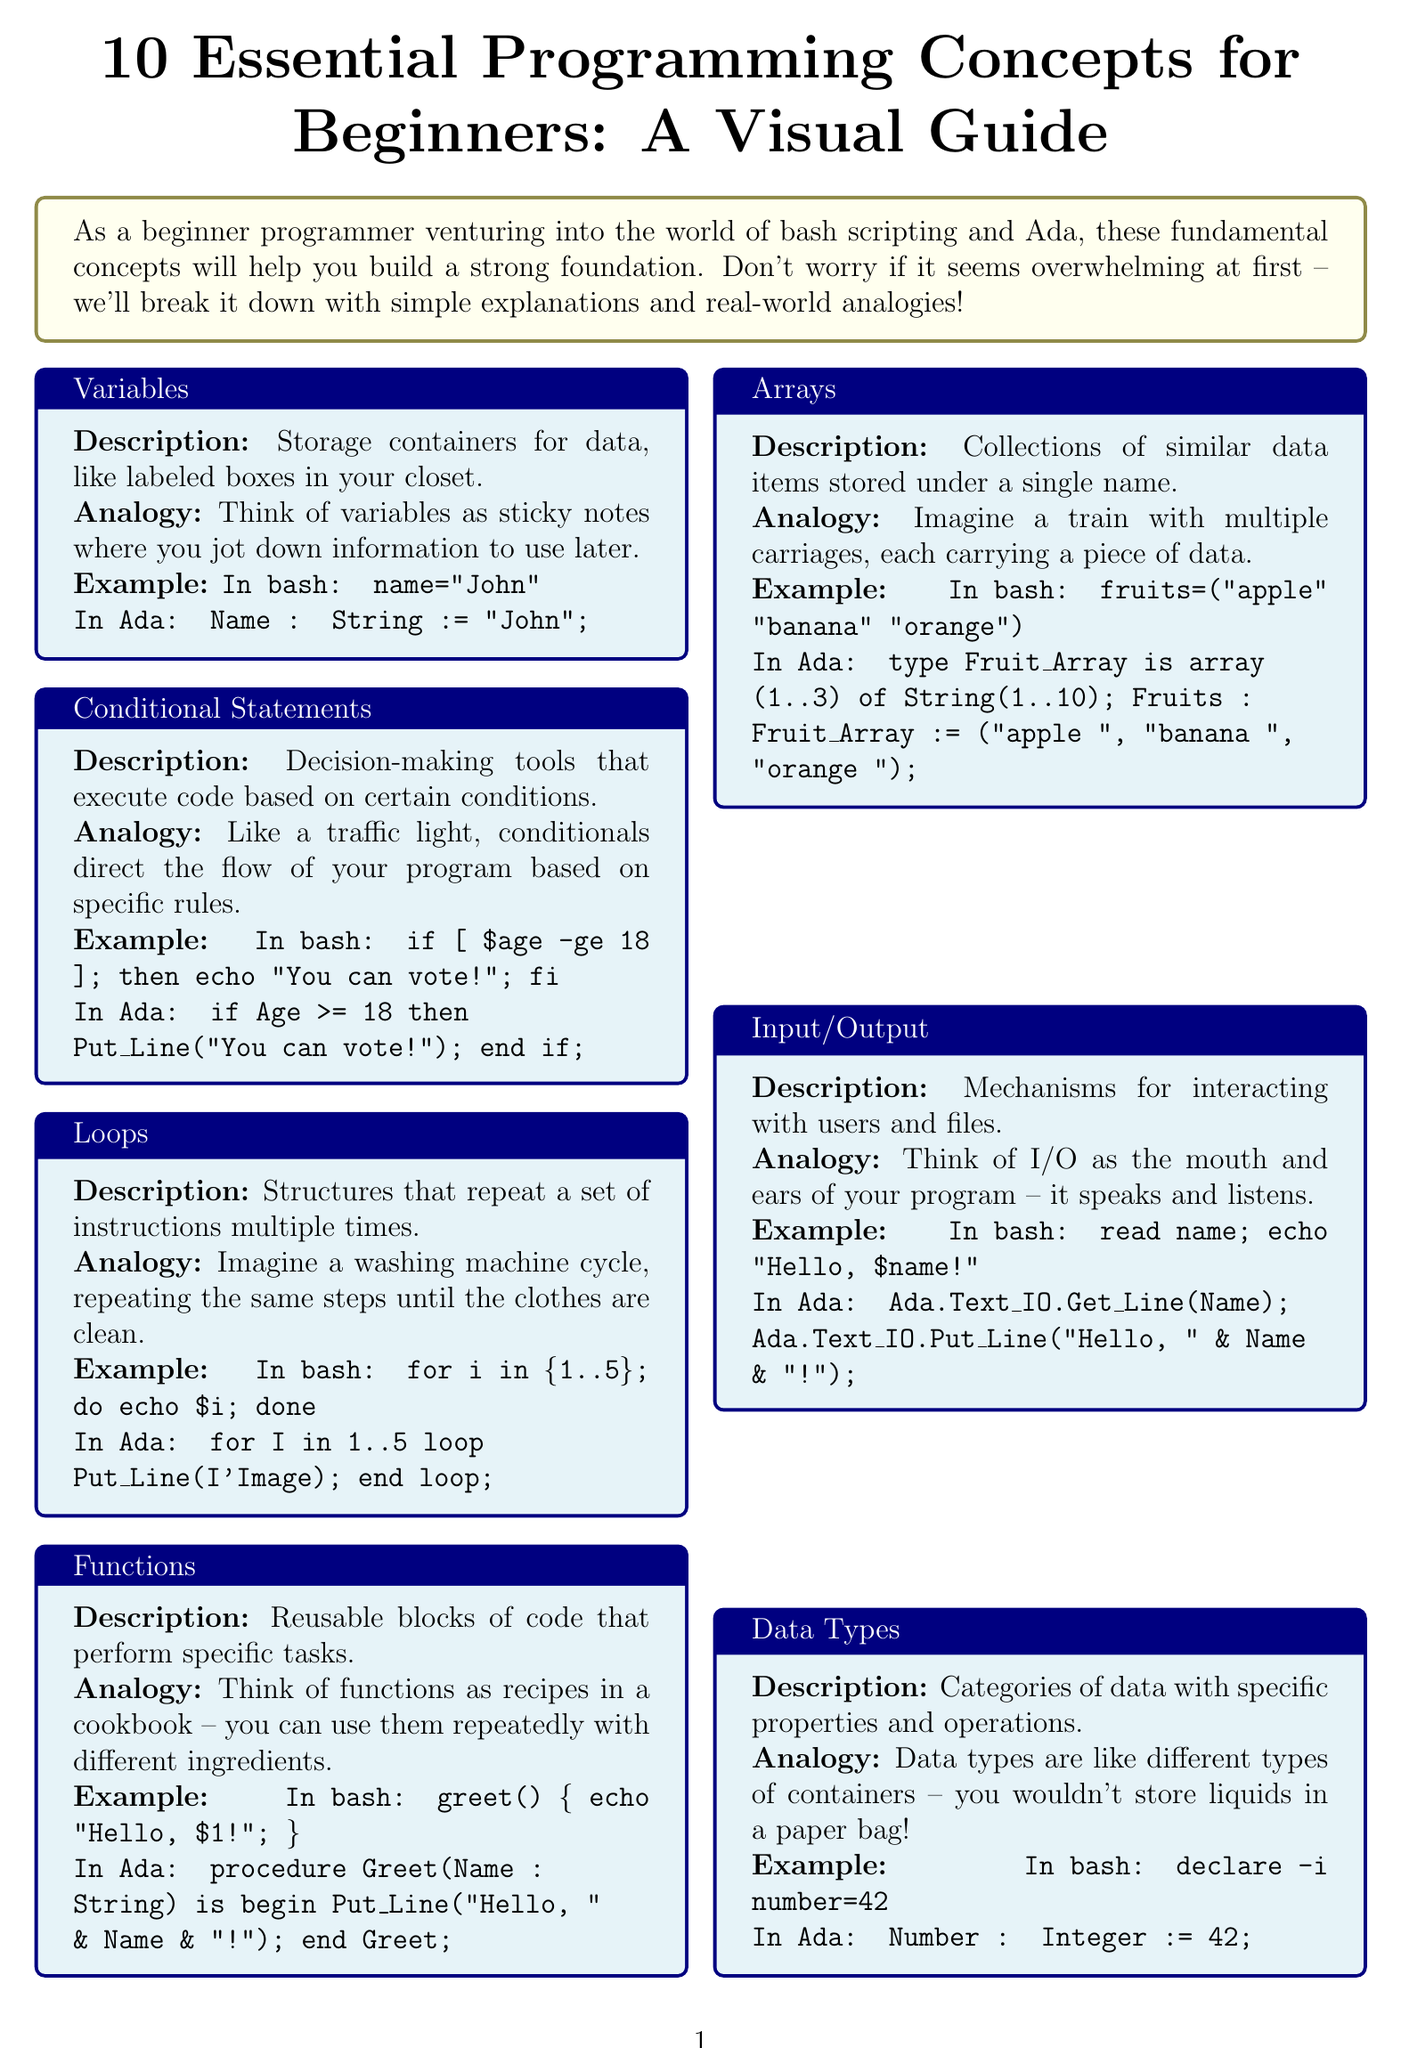What is the title of the brochure? The title of the brochure is presented prominently at the top of the document.
Answer: 10 Essential Programming Concepts for Beginners: A Visual Guide How many essential programming concepts are presented? The number of concepts is listed in the introduction and the concept section of the brochure.
Answer: 10 What analogy is used for variables? The analogy is described alongside the explanation of variables in the brochure.
Answer: Labeled boxes in your closet What is the example provided for error handling in bash? The example can be found in the section dedicated to error handling within the brochure.
Answer: command or echo "Error occurred" What do functions represent in the analogy section? The analogy for functions is discussed in the context of how they operate, showing their usefulness.
Answer: Recipes in a cookbook Which concept uses the traffic light analogy? The analogy is directly associated with one of the concepts outlined in the brochure.
Answer: Conditional Statements What color is used for the conclusion box in the document? The color is specified in the design of the brochure for the conclusion section.
Answer: Light green What is the main purpose of version control according to the brochure? The brochure specifies the function of version control in the context of programming.
Answer: Tracking and managing changes to your code What does the brochure suggest at the end about learning to program? The final thoughts encourage a specific mindset for beginners in programming.
Answer: It's a journey What does I/O stand for in the programming context in the brochure? The phrase is used in the context of input and output in programming.
Answer: Input/Output 